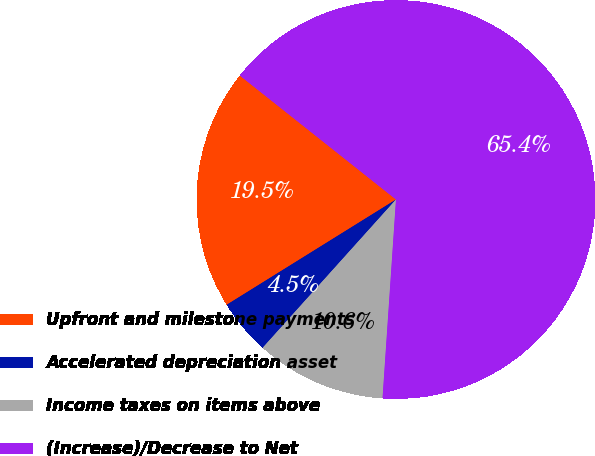Convert chart to OTSL. <chart><loc_0><loc_0><loc_500><loc_500><pie_chart><fcel>Upfront and milestone payments<fcel>Accelerated depreciation asset<fcel>Income taxes on items above<fcel>(Increase)/Decrease to Net<nl><fcel>19.53%<fcel>4.49%<fcel>10.58%<fcel>65.4%<nl></chart> 